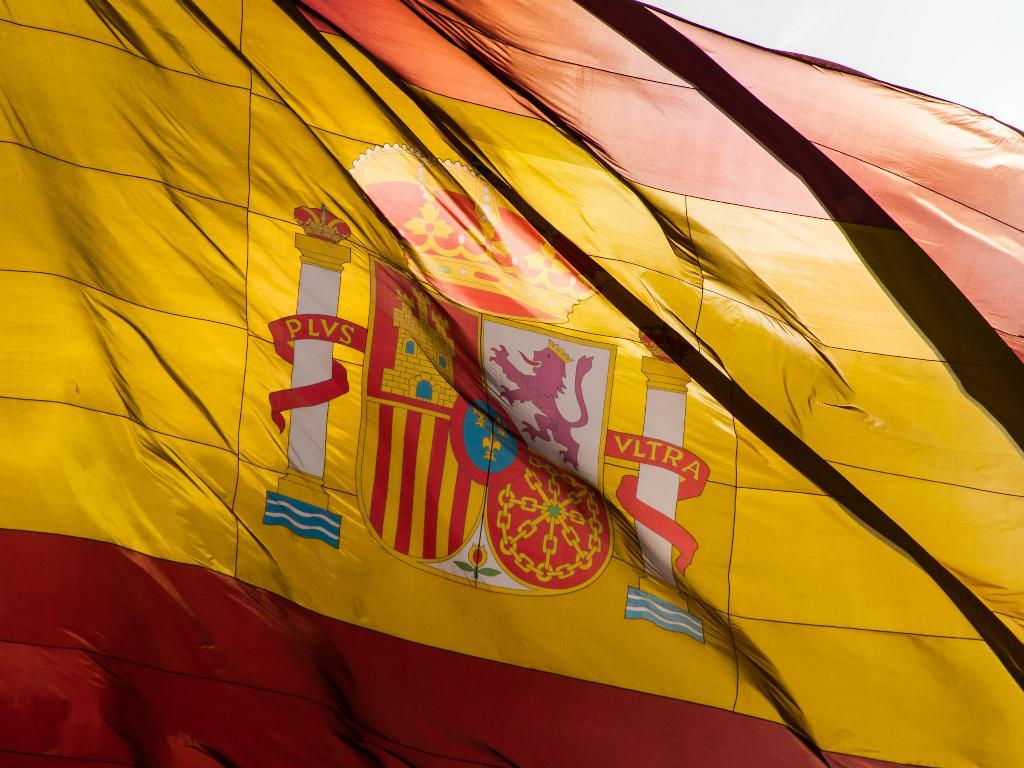Where was the image taken? The image was taken outdoors. What can be seen in the image besides the outdoor setting? There is a flag in the image. How many dogs are swimming in the lake in the image? There is no lake or dogs present in the image; it only features an outdoor setting with a flag. 